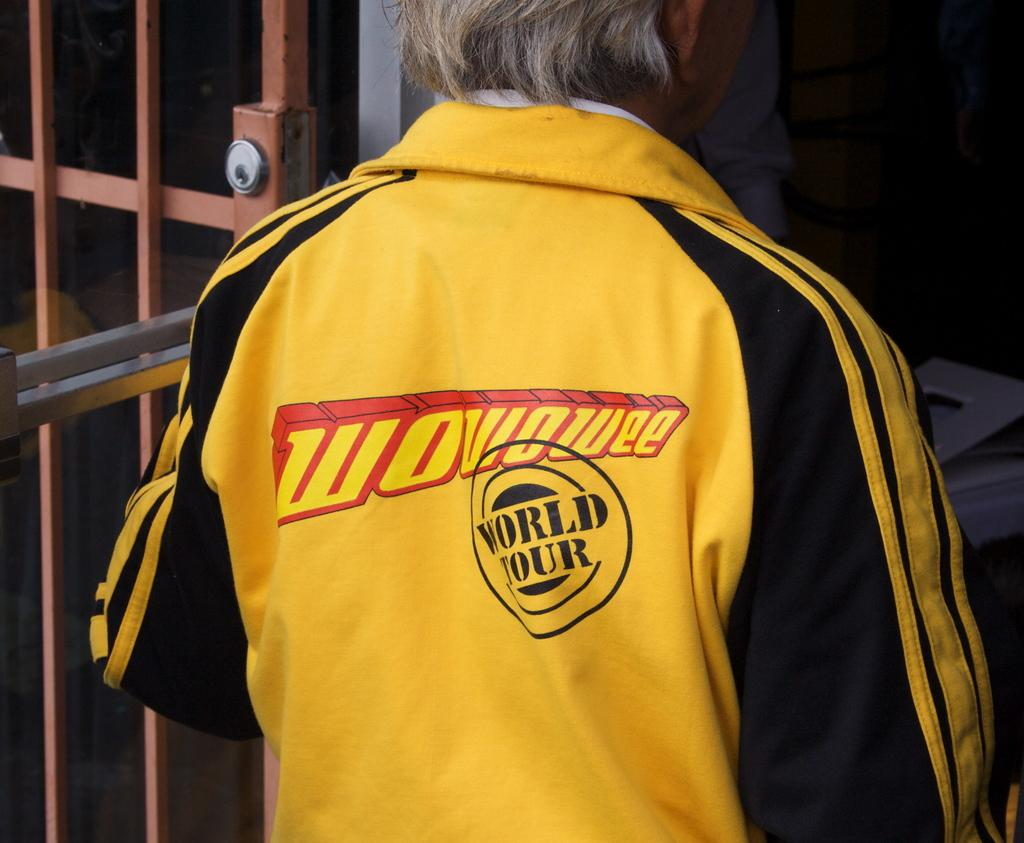<image>
Provide a brief description of the given image. A man wearing a yellow jacket that says WOWOWEE. 